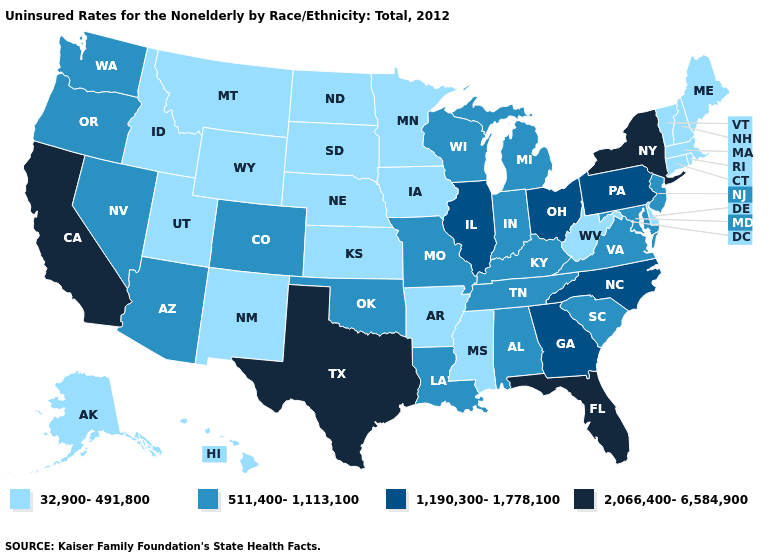Among the states that border Tennessee , does Georgia have the highest value?
Give a very brief answer. Yes. What is the lowest value in the USA?
Concise answer only. 32,900-491,800. Among the states that border Louisiana , which have the highest value?
Be succinct. Texas. Name the states that have a value in the range 511,400-1,113,100?
Concise answer only. Alabama, Arizona, Colorado, Indiana, Kentucky, Louisiana, Maryland, Michigan, Missouri, Nevada, New Jersey, Oklahoma, Oregon, South Carolina, Tennessee, Virginia, Washington, Wisconsin. Which states have the lowest value in the USA?
Write a very short answer. Alaska, Arkansas, Connecticut, Delaware, Hawaii, Idaho, Iowa, Kansas, Maine, Massachusetts, Minnesota, Mississippi, Montana, Nebraska, New Hampshire, New Mexico, North Dakota, Rhode Island, South Dakota, Utah, Vermont, West Virginia, Wyoming. What is the value of Nebraska?
Keep it brief. 32,900-491,800. What is the value of Hawaii?
Short answer required. 32,900-491,800. Name the states that have a value in the range 32,900-491,800?
Give a very brief answer. Alaska, Arkansas, Connecticut, Delaware, Hawaii, Idaho, Iowa, Kansas, Maine, Massachusetts, Minnesota, Mississippi, Montana, Nebraska, New Hampshire, New Mexico, North Dakota, Rhode Island, South Dakota, Utah, Vermont, West Virginia, Wyoming. What is the highest value in the Northeast ?
Answer briefly. 2,066,400-6,584,900. Among the states that border West Virginia , does Pennsylvania have the lowest value?
Short answer required. No. Does Nevada have a higher value than North Dakota?
Be succinct. Yes. What is the highest value in the MidWest ?
Give a very brief answer. 1,190,300-1,778,100. What is the value of New Jersey?
Keep it brief. 511,400-1,113,100. Which states have the lowest value in the Northeast?
Be succinct. Connecticut, Maine, Massachusetts, New Hampshire, Rhode Island, Vermont. Name the states that have a value in the range 511,400-1,113,100?
Be succinct. Alabama, Arizona, Colorado, Indiana, Kentucky, Louisiana, Maryland, Michigan, Missouri, Nevada, New Jersey, Oklahoma, Oregon, South Carolina, Tennessee, Virginia, Washington, Wisconsin. 